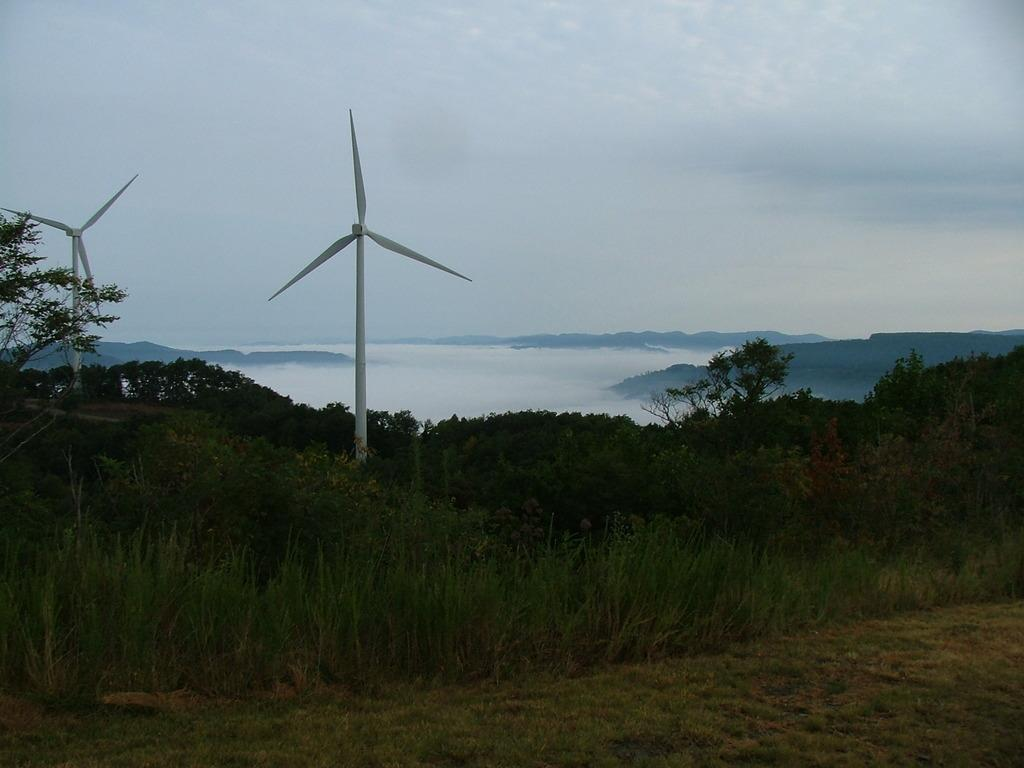What type of vegetation is in the foreground of the image? There is grass and trees in the foreground of the image. What objects are present in the foreground of the image? Wind fans are present in the foreground of the image. What type of natural landmarks can be seen in the image? Mountains are visible in the image. What atmospheric elements are present in the image? Clouds are present in the image, and the sky is visible. How many times does the person in the image sneeze? There is no person present in the image, so it is not possible to determine how many times they sneeze. 